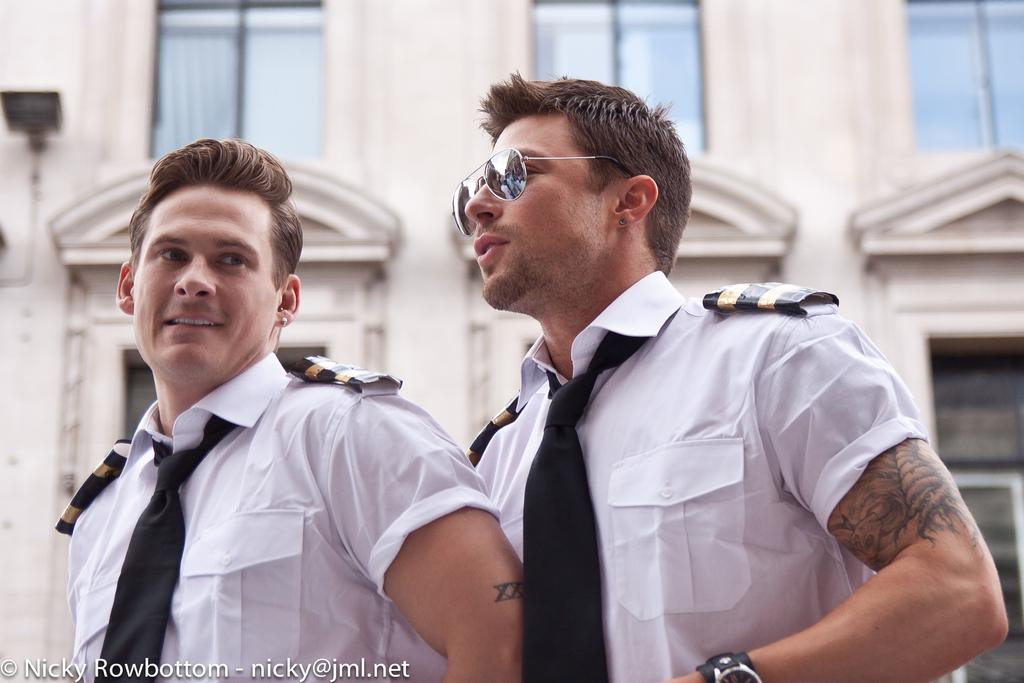How many people are in the image? There are two persons in the image. What can be seen in the background of the image? There is a building in the background of the image. Is there any additional information about the image itself? Yes, there is a watermark on the image. What type of snake can be seen slithering near the persons in the image? There is no snake present in the image; it only features two persons and a building in the background. What role does the governor play in the image? There is no governor mentioned or depicted in the image. 